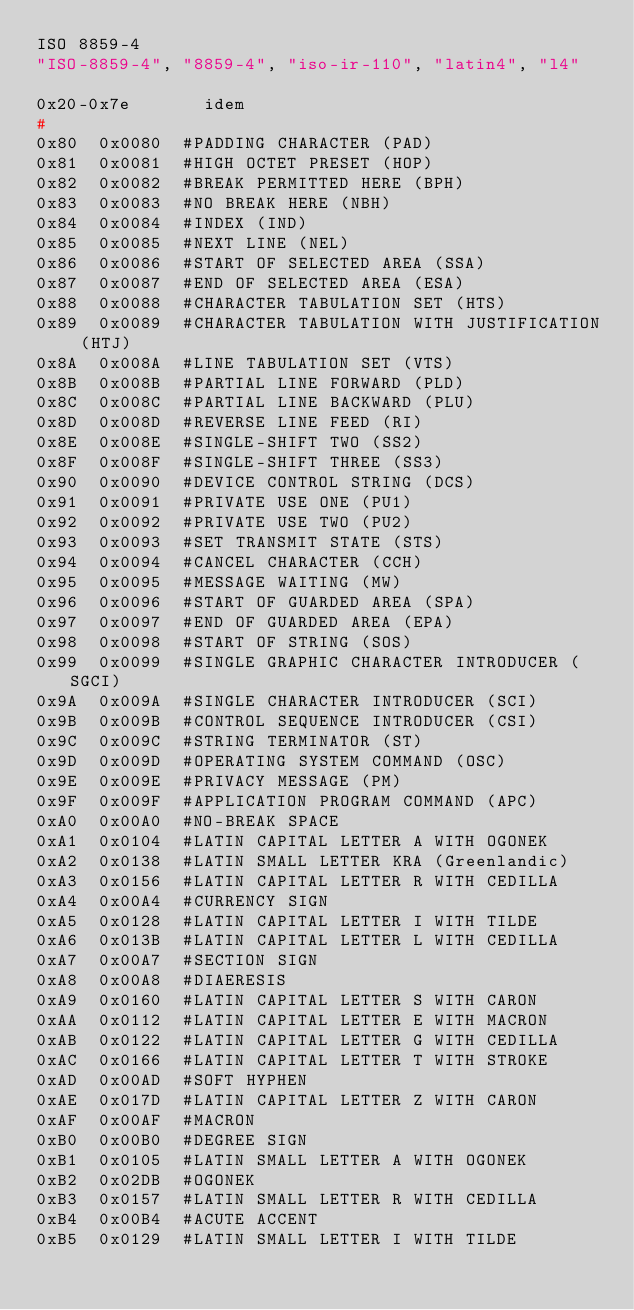Convert code to text. <code><loc_0><loc_0><loc_500><loc_500><_C++_>ISO 8859-4
"ISO-8859-4", "8859-4", "iso-ir-110", "latin4", "l4"

0x20-0x7e       idem
#
0x80	0x0080	#PADDING CHARACTER (PAD)
0x81	0x0081	#HIGH OCTET PRESET (HOP)
0x82	0x0082	#BREAK PERMITTED HERE (BPH)
0x83	0x0083	#NO BREAK HERE (NBH)
0x84	0x0084	#INDEX (IND)
0x85	0x0085	#NEXT LINE (NEL)
0x86	0x0086	#START OF SELECTED AREA (SSA)
0x87	0x0087	#END OF SELECTED AREA (ESA)
0x88	0x0088	#CHARACTER TABULATION SET (HTS)
0x89	0x0089	#CHARACTER TABULATION WITH JUSTIFICATION (HTJ)
0x8A	0x008A	#LINE TABULATION SET (VTS)
0x8B	0x008B	#PARTIAL LINE FORWARD (PLD)
0x8C	0x008C	#PARTIAL LINE BACKWARD (PLU)
0x8D	0x008D	#REVERSE LINE FEED (RI)
0x8E	0x008E	#SINGLE-SHIFT TWO (SS2)
0x8F	0x008F	#SINGLE-SHIFT THREE (SS3)
0x90	0x0090	#DEVICE CONTROL STRING (DCS)
0x91	0x0091	#PRIVATE USE ONE (PU1)
0x92	0x0092	#PRIVATE USE TWO (PU2)
0x93	0x0093	#SET TRANSMIT STATE (STS)
0x94	0x0094	#CANCEL CHARACTER (CCH)
0x95	0x0095	#MESSAGE WAITING (MW)
0x96	0x0096	#START OF GUARDED AREA (SPA)
0x97	0x0097	#END OF GUARDED AREA (EPA)
0x98	0x0098	#START OF STRING (SOS)
0x99	0x0099	#SINGLE GRAPHIC CHARACTER INTRODUCER (SGCI)
0x9A	0x009A	#SINGLE CHARACTER INTRODUCER (SCI)
0x9B	0x009B	#CONTROL SEQUENCE INTRODUCER (CSI)
0x9C	0x009C	#STRING TERMINATOR (ST)
0x9D	0x009D	#OPERATING SYSTEM COMMAND (OSC)
0x9E	0x009E	#PRIVACY MESSAGE (PM)
0x9F	0x009F	#APPLICATION PROGRAM COMMAND (APC)
0xA0	0x00A0	#NO-BREAK SPACE
0xA1	0x0104	#LATIN CAPITAL LETTER A WITH OGONEK
0xA2	0x0138	#LATIN SMALL LETTER KRA (Greenlandic)
0xA3	0x0156	#LATIN CAPITAL LETTER R WITH CEDILLA
0xA4	0x00A4	#CURRENCY SIGN
0xA5	0x0128	#LATIN CAPITAL LETTER I WITH TILDE
0xA6	0x013B	#LATIN CAPITAL LETTER L WITH CEDILLA
0xA7	0x00A7	#SECTION SIGN
0xA8	0x00A8	#DIAERESIS
0xA9	0x0160	#LATIN CAPITAL LETTER S WITH CARON
0xAA	0x0112	#LATIN CAPITAL LETTER E WITH MACRON
0xAB	0x0122	#LATIN CAPITAL LETTER G WITH CEDILLA
0xAC	0x0166	#LATIN CAPITAL LETTER T WITH STROKE
0xAD	0x00AD	#SOFT HYPHEN
0xAE	0x017D	#LATIN CAPITAL LETTER Z WITH CARON
0xAF	0x00AF	#MACRON
0xB0	0x00B0	#DEGREE SIGN
0xB1	0x0105	#LATIN SMALL LETTER A WITH OGONEK
0xB2	0x02DB	#OGONEK
0xB3	0x0157	#LATIN SMALL LETTER R WITH CEDILLA
0xB4	0x00B4	#ACUTE ACCENT
0xB5	0x0129	#LATIN SMALL LETTER I WITH TILDE</code> 